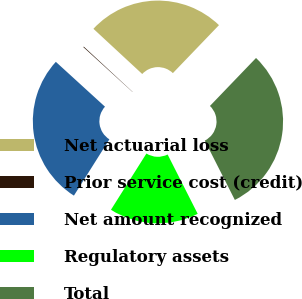Convert chart to OTSL. <chart><loc_0><loc_0><loc_500><loc_500><pie_chart><fcel>Net actuarial loss<fcel>Prior service cost (credit)<fcel>Net amount recognized<fcel>Regulatory assets<fcel>Total<nl><fcel>25.29%<fcel>0.12%<fcel>27.82%<fcel>16.42%<fcel>30.35%<nl></chart> 